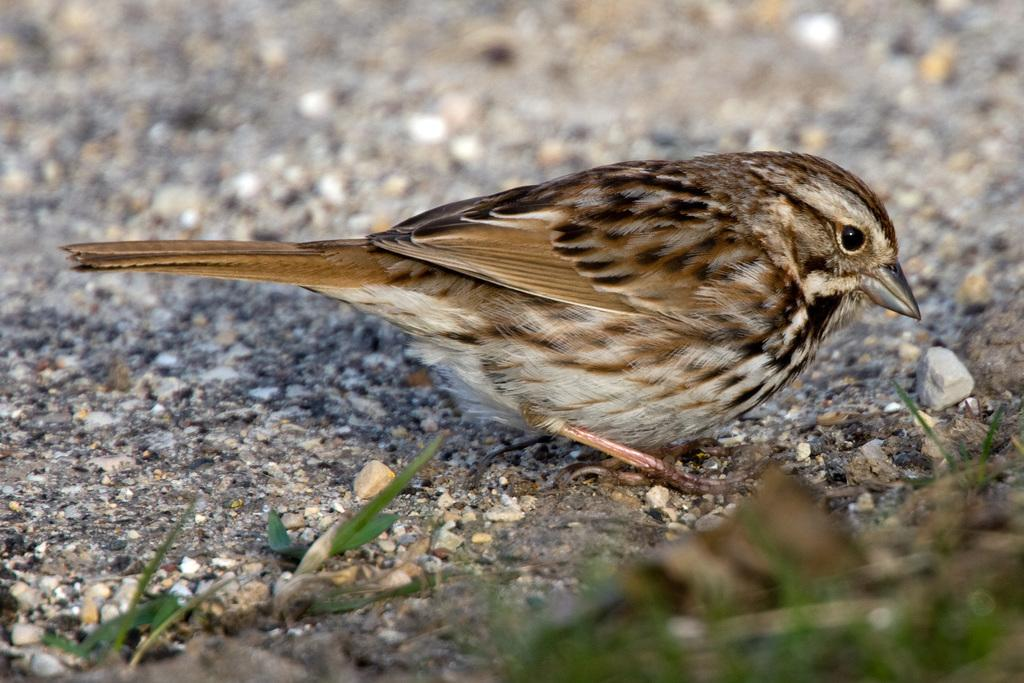What type of animal can be seen in the image? There is a bird in the image. Where is the bird located? The bird is on the ground in the image. In which direction is the bird facing? The bird is facing towards the right side in the image. What can be seen in the background of the image? There are many stones and a few leaves visible at the bottom of the image. What type of cheese is the bird holding in its beak in the image? There is no cheese present in the image; the bird is not holding anything in its beak. 